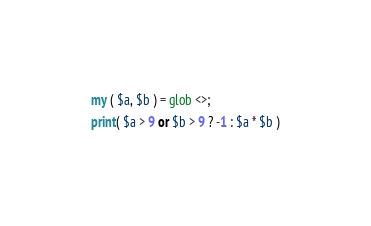<code> <loc_0><loc_0><loc_500><loc_500><_Perl_>my ( $a, $b ) = glob <>;
print( $a > 9 or $b > 9 ? -1 : $a * $b )</code> 